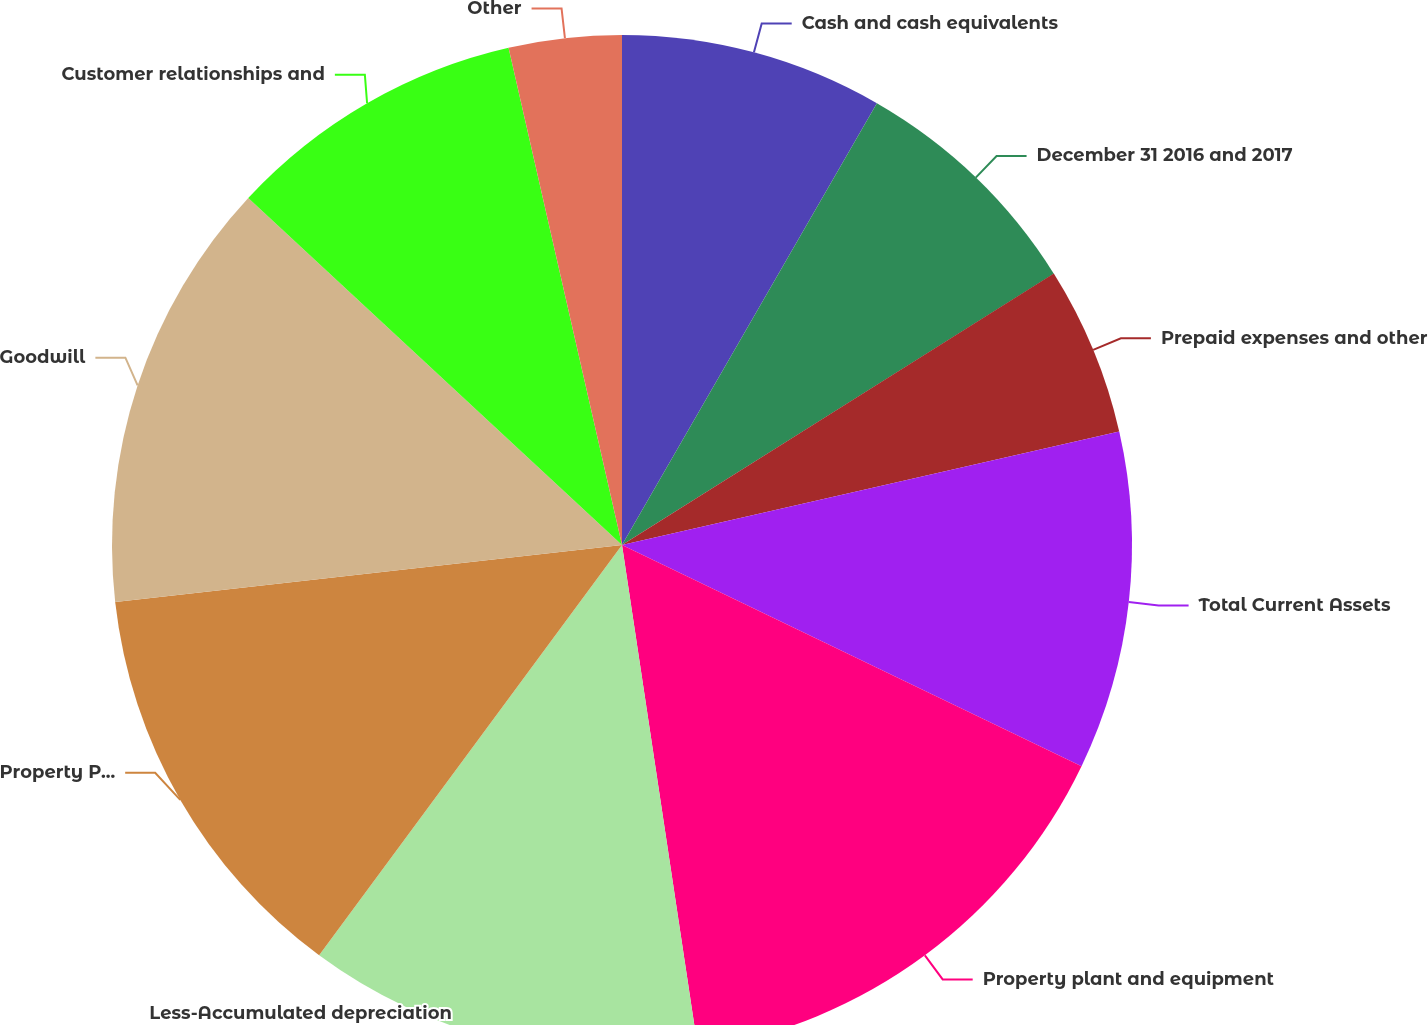Convert chart to OTSL. <chart><loc_0><loc_0><loc_500><loc_500><pie_chart><fcel>Cash and cash equivalents<fcel>December 31 2016 and 2017<fcel>Prepaid expenses and other<fcel>Total Current Assets<fcel>Property plant and equipment<fcel>Less-Accumulated depreciation<fcel>Property Plant and Equipment<fcel>Goodwill<fcel>Customer relationships and<fcel>Other<nl><fcel>8.33%<fcel>7.74%<fcel>5.36%<fcel>10.71%<fcel>15.48%<fcel>12.5%<fcel>13.1%<fcel>13.69%<fcel>9.52%<fcel>3.57%<nl></chart> 